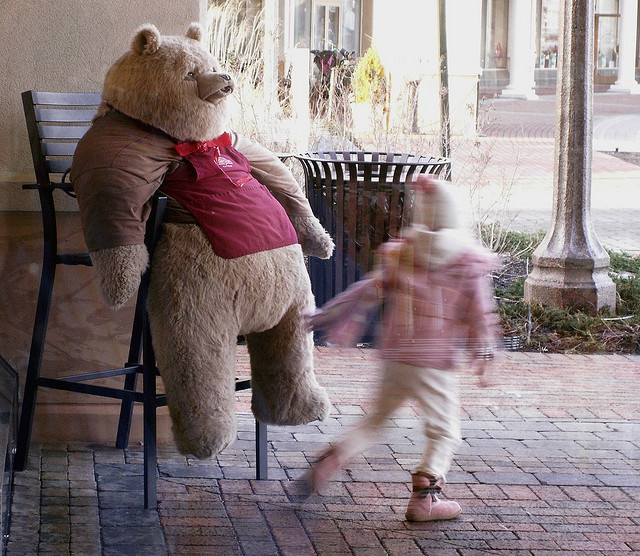Describe the objects in this image and their specific colors. I can see teddy bear in gray, black, and maroon tones, people in gray, brown, darkgray, and lightgray tones, chair in gray and black tones, and chair in gray and black tones in this image. 